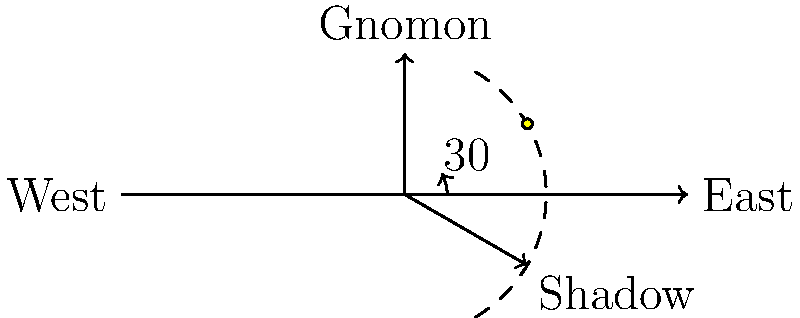As a UN peacekeeper, you're stationed in an unfamiliar location without access to your watch or other timekeeping devices. Using your knowledge of the sun's position and shadows, estimate the local time based on the diagram. Assume it's a spring or fall day near the equator, where the sun rises at 6:00 AM and sets at 6:00 PM. To estimate the local time using the sun's position and shadows, we can follow these steps:

1. Observe that the sun moves 15° per hour (360° / 24 hours).

2. In the diagram, the shadow forms a 30° angle with the East-West line.

3. Since we're near the equator during spring or fall, we can assume the sun rises directly in the East at 6:00 AM and sets directly in the West at 6:00 PM.

4. The 30° angle indicates that 2 hours have passed since sunrise (30° / 15° per hour = 2 hours).

5. Calculate the local time:
   6:00 AM (sunrise) + 2 hours = 8:00 AM

Therefore, based on the shadow's position in the diagram, we can estimate that the local time is approximately 8:00 AM.

This method can be crucial for peacekeepers operating in remote areas without access to standard timekeeping devices, allowing them to coordinate activities and maintain situational awareness.
Answer: 8:00 AM 